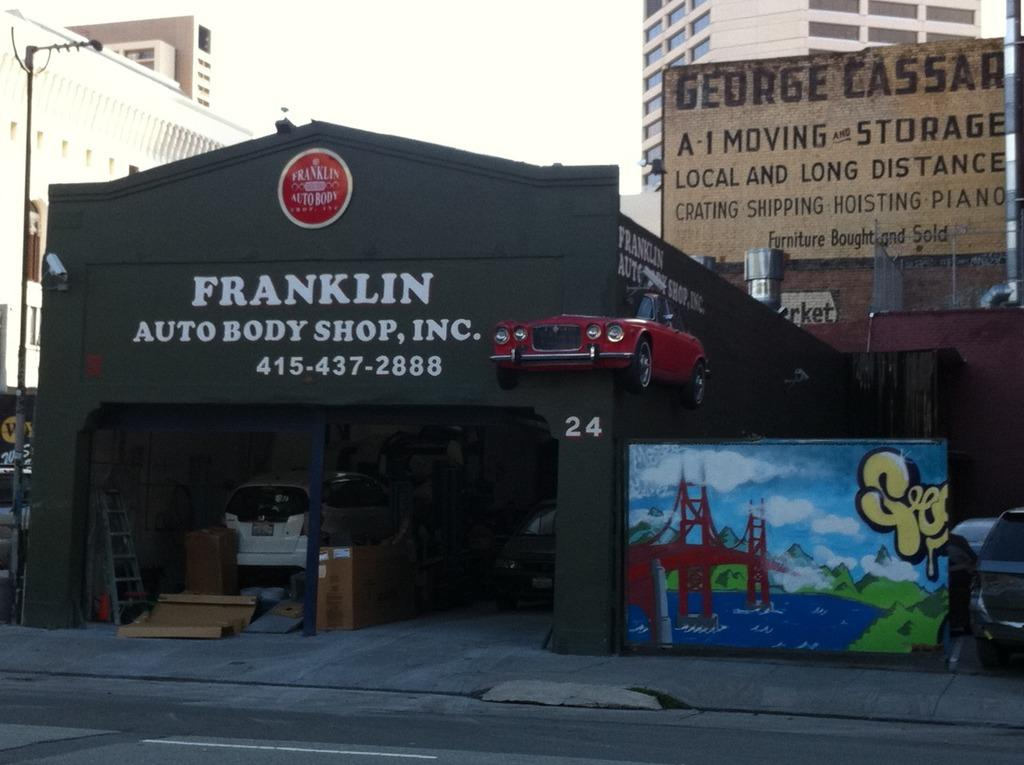<image>
Write a terse but informative summary of the picture. A Franklin Auto Body shop sits in front of a storage building. 